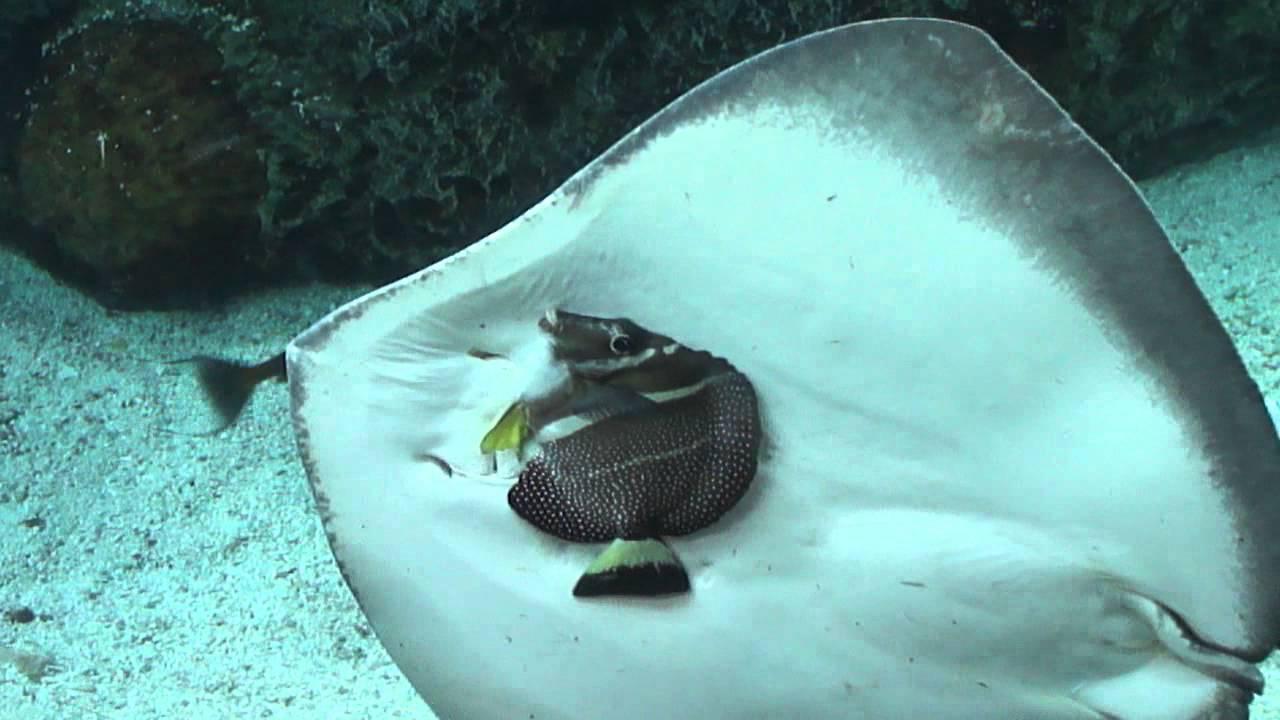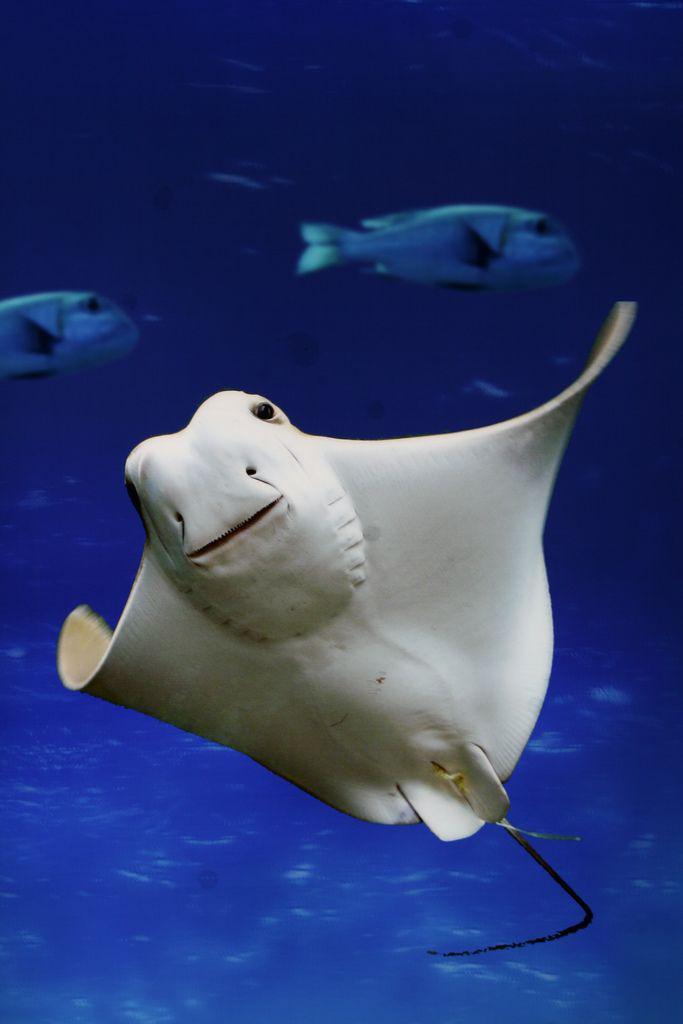The first image is the image on the left, the second image is the image on the right. For the images displayed, is the sentence "The creature in the image on the left appears to be smiling." factually correct? Answer yes or no. No. 